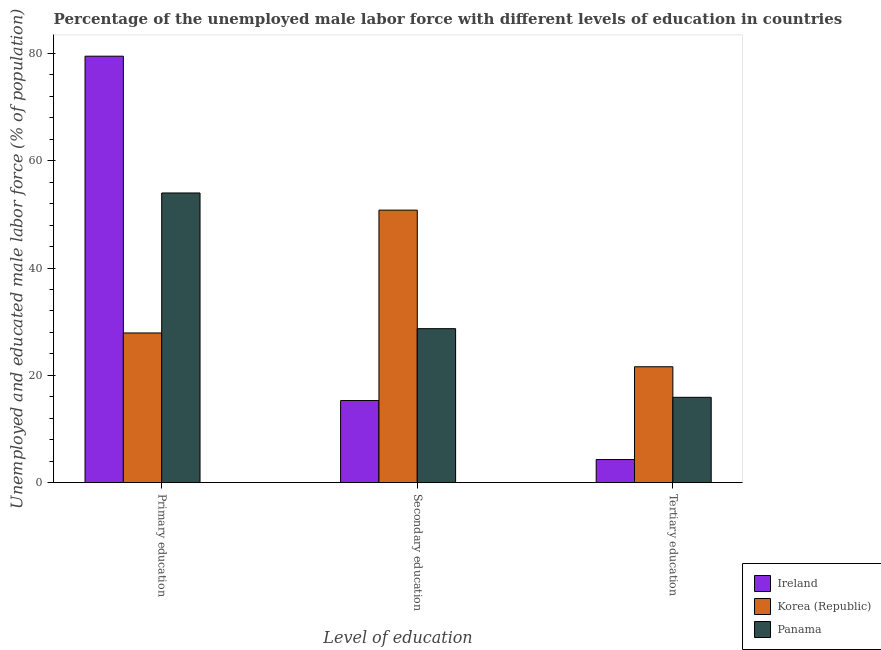Are the number of bars on each tick of the X-axis equal?
Offer a very short reply. Yes. How many bars are there on the 2nd tick from the right?
Provide a succinct answer. 3. What is the label of the 2nd group of bars from the left?
Provide a succinct answer. Secondary education. What is the percentage of male labor force who received tertiary education in Ireland?
Offer a very short reply. 4.3. Across all countries, what is the maximum percentage of male labor force who received primary education?
Make the answer very short. 79.5. Across all countries, what is the minimum percentage of male labor force who received primary education?
Provide a short and direct response. 27.9. In which country was the percentage of male labor force who received primary education maximum?
Provide a short and direct response. Ireland. In which country was the percentage of male labor force who received secondary education minimum?
Offer a very short reply. Ireland. What is the total percentage of male labor force who received primary education in the graph?
Provide a succinct answer. 161.4. What is the difference between the percentage of male labor force who received secondary education in Panama and that in Korea (Republic)?
Keep it short and to the point. -22.1. What is the difference between the percentage of male labor force who received primary education in Korea (Republic) and the percentage of male labor force who received tertiary education in Ireland?
Keep it short and to the point. 23.6. What is the average percentage of male labor force who received primary education per country?
Make the answer very short. 53.8. What is the difference between the percentage of male labor force who received secondary education and percentage of male labor force who received tertiary education in Korea (Republic)?
Make the answer very short. 29.2. In how many countries, is the percentage of male labor force who received secondary education greater than 24 %?
Provide a succinct answer. 2. What is the ratio of the percentage of male labor force who received primary education in Ireland to that in Panama?
Offer a terse response. 1.47. Is the percentage of male labor force who received tertiary education in Panama less than that in Ireland?
Offer a terse response. No. Is the difference between the percentage of male labor force who received tertiary education in Korea (Republic) and Ireland greater than the difference between the percentage of male labor force who received secondary education in Korea (Republic) and Ireland?
Offer a terse response. No. What is the difference between the highest and the second highest percentage of male labor force who received secondary education?
Your answer should be very brief. 22.1. What is the difference between the highest and the lowest percentage of male labor force who received primary education?
Give a very brief answer. 51.6. In how many countries, is the percentage of male labor force who received secondary education greater than the average percentage of male labor force who received secondary education taken over all countries?
Your answer should be compact. 1. What does the 2nd bar from the left in Tertiary education represents?
Ensure brevity in your answer.  Korea (Republic). Is it the case that in every country, the sum of the percentage of male labor force who received primary education and percentage of male labor force who received secondary education is greater than the percentage of male labor force who received tertiary education?
Provide a succinct answer. Yes. How many countries are there in the graph?
Give a very brief answer. 3. What is the difference between two consecutive major ticks on the Y-axis?
Ensure brevity in your answer.  20. Are the values on the major ticks of Y-axis written in scientific E-notation?
Your answer should be compact. No. Does the graph contain grids?
Offer a very short reply. No. Where does the legend appear in the graph?
Your response must be concise. Bottom right. How are the legend labels stacked?
Give a very brief answer. Vertical. What is the title of the graph?
Your answer should be compact. Percentage of the unemployed male labor force with different levels of education in countries. Does "Kenya" appear as one of the legend labels in the graph?
Offer a very short reply. No. What is the label or title of the X-axis?
Offer a terse response. Level of education. What is the label or title of the Y-axis?
Your answer should be very brief. Unemployed and educated male labor force (% of population). What is the Unemployed and educated male labor force (% of population) of Ireland in Primary education?
Ensure brevity in your answer.  79.5. What is the Unemployed and educated male labor force (% of population) in Korea (Republic) in Primary education?
Keep it short and to the point. 27.9. What is the Unemployed and educated male labor force (% of population) of Ireland in Secondary education?
Your answer should be very brief. 15.3. What is the Unemployed and educated male labor force (% of population) in Korea (Republic) in Secondary education?
Your answer should be compact. 50.8. What is the Unemployed and educated male labor force (% of population) in Panama in Secondary education?
Offer a very short reply. 28.7. What is the Unemployed and educated male labor force (% of population) in Ireland in Tertiary education?
Provide a succinct answer. 4.3. What is the Unemployed and educated male labor force (% of population) of Korea (Republic) in Tertiary education?
Offer a terse response. 21.6. What is the Unemployed and educated male labor force (% of population) in Panama in Tertiary education?
Offer a very short reply. 15.9. Across all Level of education, what is the maximum Unemployed and educated male labor force (% of population) of Ireland?
Provide a succinct answer. 79.5. Across all Level of education, what is the maximum Unemployed and educated male labor force (% of population) of Korea (Republic)?
Offer a very short reply. 50.8. Across all Level of education, what is the maximum Unemployed and educated male labor force (% of population) of Panama?
Ensure brevity in your answer.  54. Across all Level of education, what is the minimum Unemployed and educated male labor force (% of population) in Ireland?
Provide a short and direct response. 4.3. Across all Level of education, what is the minimum Unemployed and educated male labor force (% of population) in Korea (Republic)?
Make the answer very short. 21.6. Across all Level of education, what is the minimum Unemployed and educated male labor force (% of population) of Panama?
Your response must be concise. 15.9. What is the total Unemployed and educated male labor force (% of population) in Ireland in the graph?
Offer a terse response. 99.1. What is the total Unemployed and educated male labor force (% of population) of Korea (Republic) in the graph?
Your answer should be compact. 100.3. What is the total Unemployed and educated male labor force (% of population) in Panama in the graph?
Provide a succinct answer. 98.6. What is the difference between the Unemployed and educated male labor force (% of population) in Ireland in Primary education and that in Secondary education?
Offer a very short reply. 64.2. What is the difference between the Unemployed and educated male labor force (% of population) of Korea (Republic) in Primary education and that in Secondary education?
Provide a short and direct response. -22.9. What is the difference between the Unemployed and educated male labor force (% of population) of Panama in Primary education and that in Secondary education?
Provide a succinct answer. 25.3. What is the difference between the Unemployed and educated male labor force (% of population) of Ireland in Primary education and that in Tertiary education?
Your answer should be very brief. 75.2. What is the difference between the Unemployed and educated male labor force (% of population) in Panama in Primary education and that in Tertiary education?
Provide a succinct answer. 38.1. What is the difference between the Unemployed and educated male labor force (% of population) in Korea (Republic) in Secondary education and that in Tertiary education?
Provide a succinct answer. 29.2. What is the difference between the Unemployed and educated male labor force (% of population) in Panama in Secondary education and that in Tertiary education?
Ensure brevity in your answer.  12.8. What is the difference between the Unemployed and educated male labor force (% of population) of Ireland in Primary education and the Unemployed and educated male labor force (% of population) of Korea (Republic) in Secondary education?
Offer a terse response. 28.7. What is the difference between the Unemployed and educated male labor force (% of population) in Ireland in Primary education and the Unemployed and educated male labor force (% of population) in Panama in Secondary education?
Offer a very short reply. 50.8. What is the difference between the Unemployed and educated male labor force (% of population) in Korea (Republic) in Primary education and the Unemployed and educated male labor force (% of population) in Panama in Secondary education?
Your answer should be compact. -0.8. What is the difference between the Unemployed and educated male labor force (% of population) in Ireland in Primary education and the Unemployed and educated male labor force (% of population) in Korea (Republic) in Tertiary education?
Your answer should be very brief. 57.9. What is the difference between the Unemployed and educated male labor force (% of population) of Ireland in Primary education and the Unemployed and educated male labor force (% of population) of Panama in Tertiary education?
Give a very brief answer. 63.6. What is the difference between the Unemployed and educated male labor force (% of population) of Korea (Republic) in Primary education and the Unemployed and educated male labor force (% of population) of Panama in Tertiary education?
Your answer should be very brief. 12. What is the difference between the Unemployed and educated male labor force (% of population) of Korea (Republic) in Secondary education and the Unemployed and educated male labor force (% of population) of Panama in Tertiary education?
Make the answer very short. 34.9. What is the average Unemployed and educated male labor force (% of population) in Ireland per Level of education?
Your answer should be compact. 33.03. What is the average Unemployed and educated male labor force (% of population) of Korea (Republic) per Level of education?
Your response must be concise. 33.43. What is the average Unemployed and educated male labor force (% of population) of Panama per Level of education?
Your response must be concise. 32.87. What is the difference between the Unemployed and educated male labor force (% of population) of Ireland and Unemployed and educated male labor force (% of population) of Korea (Republic) in Primary education?
Your answer should be very brief. 51.6. What is the difference between the Unemployed and educated male labor force (% of population) of Ireland and Unemployed and educated male labor force (% of population) of Panama in Primary education?
Offer a terse response. 25.5. What is the difference between the Unemployed and educated male labor force (% of population) in Korea (Republic) and Unemployed and educated male labor force (% of population) in Panama in Primary education?
Your response must be concise. -26.1. What is the difference between the Unemployed and educated male labor force (% of population) in Ireland and Unemployed and educated male labor force (% of population) in Korea (Republic) in Secondary education?
Offer a terse response. -35.5. What is the difference between the Unemployed and educated male labor force (% of population) in Korea (Republic) and Unemployed and educated male labor force (% of population) in Panama in Secondary education?
Give a very brief answer. 22.1. What is the difference between the Unemployed and educated male labor force (% of population) of Ireland and Unemployed and educated male labor force (% of population) of Korea (Republic) in Tertiary education?
Offer a very short reply. -17.3. What is the difference between the Unemployed and educated male labor force (% of population) of Ireland and Unemployed and educated male labor force (% of population) of Panama in Tertiary education?
Give a very brief answer. -11.6. What is the ratio of the Unemployed and educated male labor force (% of population) in Ireland in Primary education to that in Secondary education?
Your answer should be compact. 5.2. What is the ratio of the Unemployed and educated male labor force (% of population) of Korea (Republic) in Primary education to that in Secondary education?
Offer a very short reply. 0.55. What is the ratio of the Unemployed and educated male labor force (% of population) in Panama in Primary education to that in Secondary education?
Give a very brief answer. 1.88. What is the ratio of the Unemployed and educated male labor force (% of population) in Ireland in Primary education to that in Tertiary education?
Provide a succinct answer. 18.49. What is the ratio of the Unemployed and educated male labor force (% of population) of Korea (Republic) in Primary education to that in Tertiary education?
Keep it short and to the point. 1.29. What is the ratio of the Unemployed and educated male labor force (% of population) in Panama in Primary education to that in Tertiary education?
Give a very brief answer. 3.4. What is the ratio of the Unemployed and educated male labor force (% of population) of Ireland in Secondary education to that in Tertiary education?
Make the answer very short. 3.56. What is the ratio of the Unemployed and educated male labor force (% of population) of Korea (Republic) in Secondary education to that in Tertiary education?
Make the answer very short. 2.35. What is the ratio of the Unemployed and educated male labor force (% of population) in Panama in Secondary education to that in Tertiary education?
Give a very brief answer. 1.8. What is the difference between the highest and the second highest Unemployed and educated male labor force (% of population) of Ireland?
Your answer should be compact. 64.2. What is the difference between the highest and the second highest Unemployed and educated male labor force (% of population) of Korea (Republic)?
Provide a succinct answer. 22.9. What is the difference between the highest and the second highest Unemployed and educated male labor force (% of population) in Panama?
Your answer should be very brief. 25.3. What is the difference between the highest and the lowest Unemployed and educated male labor force (% of population) of Ireland?
Ensure brevity in your answer.  75.2. What is the difference between the highest and the lowest Unemployed and educated male labor force (% of population) in Korea (Republic)?
Your answer should be very brief. 29.2. What is the difference between the highest and the lowest Unemployed and educated male labor force (% of population) of Panama?
Your answer should be compact. 38.1. 